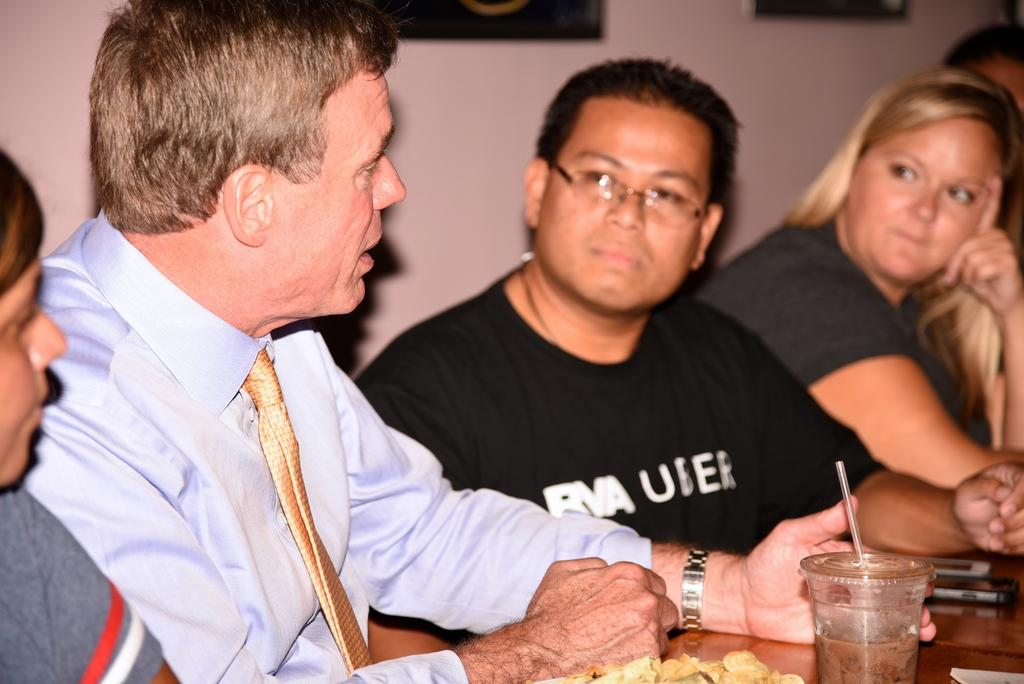What is happening in the image? There is a group of people in the image, and they are seated. What objects are on the table in the image? There are cups and a mobile phone on the table. What type of fruit is being used as a paperweight for the mobile phone in the image? There is no fruit present in the image, and the mobile phone is not being held down by any object. 